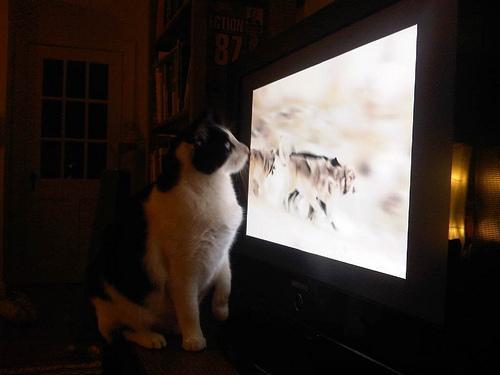How many cats are in the picture?
Give a very brief answer. 1. 